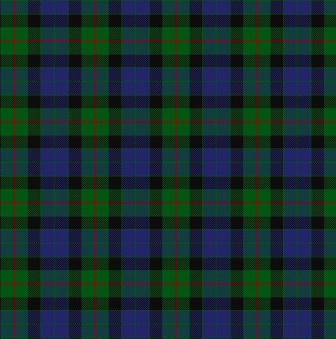Can you describe what you see in this image? The image shows a tartan plaid design, characterized by a repeating grid of squares and rectangles in green, blue, black, and red. These colors intersect in a harmonious pattern, creating a layered and structured look typical of traditional tartan designs. 